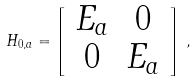Convert formula to latex. <formula><loc_0><loc_0><loc_500><loc_500>H _ { 0 , a } = \left [ \begin{array} { c c } E _ { a } & 0 \\ 0 & E _ { a } \end{array} \right ] \, ,</formula> 